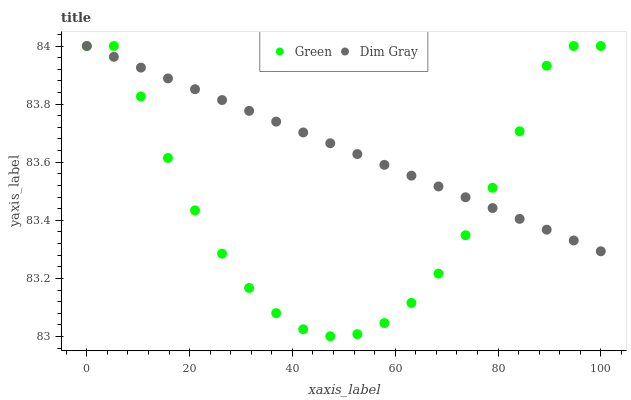Does Green have the minimum area under the curve?
Answer yes or no. Yes. Does Dim Gray have the maximum area under the curve?
Answer yes or no. Yes. Does Green have the maximum area under the curve?
Answer yes or no. No. Is Dim Gray the smoothest?
Answer yes or no. Yes. Is Green the roughest?
Answer yes or no. Yes. Is Green the smoothest?
Answer yes or no. No. Does Green have the lowest value?
Answer yes or no. Yes. Does Green have the highest value?
Answer yes or no. Yes. Does Green intersect Dim Gray?
Answer yes or no. Yes. Is Green less than Dim Gray?
Answer yes or no. No. Is Green greater than Dim Gray?
Answer yes or no. No. 